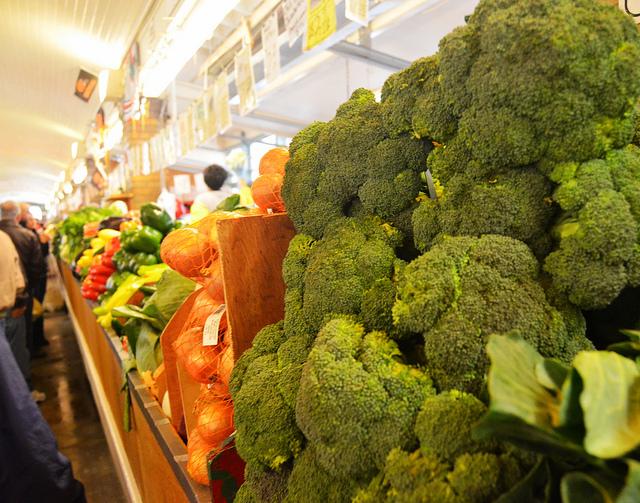Is this the vegetable section in a supermarket?
Short answer required. Yes. What vegetable is on the right of this scene?
Write a very short answer. Broccoli. Are the lights on?
Concise answer only. Yes. 